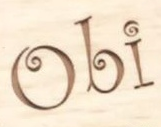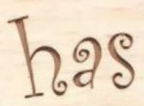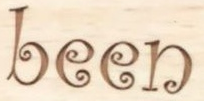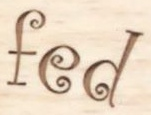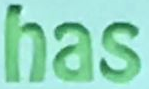What text appears in these images from left to right, separated by a semicolon? Obi; has; been; fed; has 